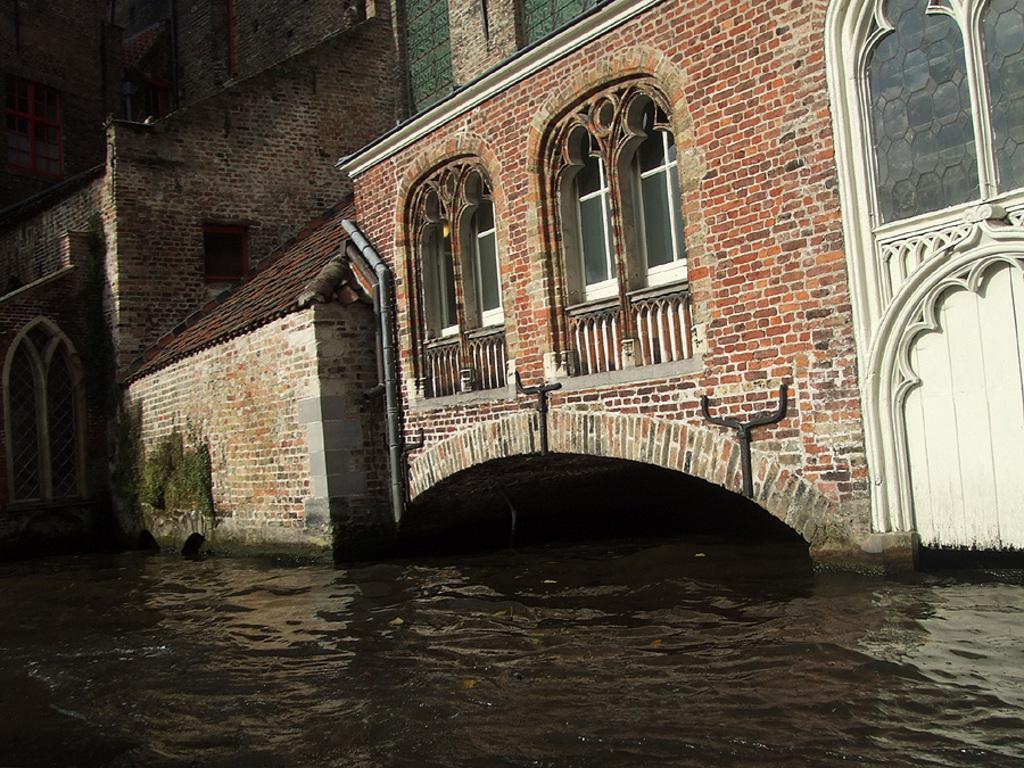Please provide a concise description of this image. In this image there are buildings one beside the other. Below the buildings there is water. In the middle there are two windows. On the right side top there is a glass window. Beside the window there is a pipe. 